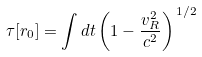<formula> <loc_0><loc_0><loc_500><loc_500>\tau [ { r } _ { 0 } ] = \int d t \left ( 1 - \frac { { v } _ { R } ^ { 2 } } { c ^ { 2 } } \right ) ^ { \, 1 / 2 }</formula> 